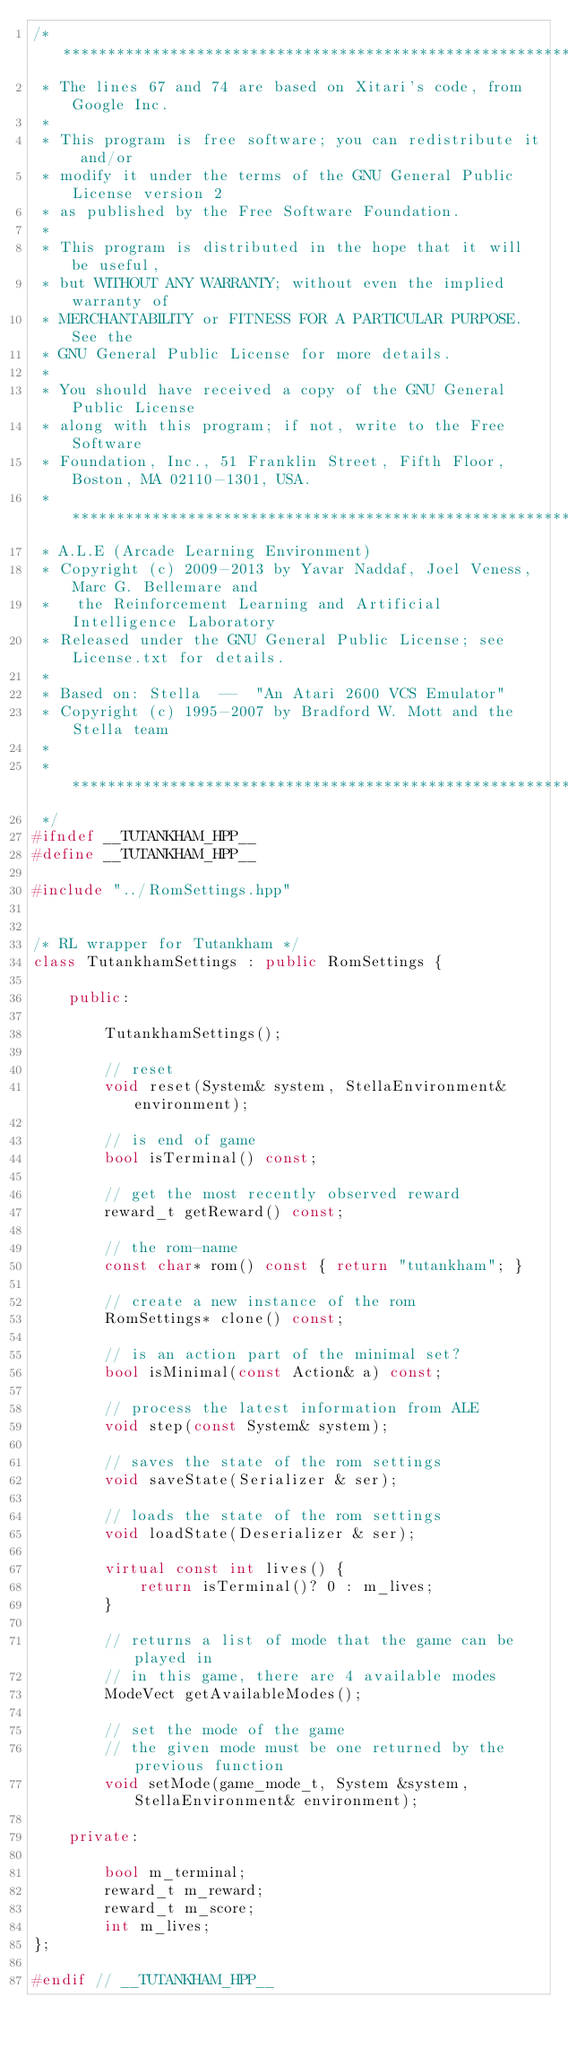Convert code to text. <code><loc_0><loc_0><loc_500><loc_500><_C++_>/* *****************************************************************************
 * The lines 67 and 74 are based on Xitari's code, from Google Inc.
 *
 * This program is free software; you can redistribute it and/or
 * modify it under the terms of the GNU General Public License version 2
 * as published by the Free Software Foundation.
 *
 * This program is distributed in the hope that it will be useful,
 * but WITHOUT ANY WARRANTY; without even the implied warranty of
 * MERCHANTABILITY or FITNESS FOR A PARTICULAR PURPOSE. See the
 * GNU General Public License for more details.
 *
 * You should have received a copy of the GNU General Public License
 * along with this program; if not, write to the Free Software
 * Foundation, Inc., 51 Franklin Street, Fifth Floor, Boston, MA 02110-1301, USA.
 * *****************************************************************************
 * A.L.E (Arcade Learning Environment)
 * Copyright (c) 2009-2013 by Yavar Naddaf, Joel Veness, Marc G. Bellemare and 
 *   the Reinforcement Learning and Artificial Intelligence Laboratory
 * Released under the GNU General Public License; see License.txt for details. 
 *
 * Based on: Stella  --  "An Atari 2600 VCS Emulator"
 * Copyright (c) 1995-2007 by Bradford W. Mott and the Stella team
 *
 * *****************************************************************************
 */
#ifndef __TUTANKHAM_HPP__
#define __TUTANKHAM_HPP__

#include "../RomSettings.hpp"


/* RL wrapper for Tutankham */
class TutankhamSettings : public RomSettings {

    public:

        TutankhamSettings();

        // reset
        void reset(System& system, StellaEnvironment& environment);

        // is end of game
        bool isTerminal() const;

        // get the most recently observed reward
        reward_t getReward() const;

        // the rom-name
        const char* rom() const { return "tutankham"; }

        // create a new instance of the rom
        RomSettings* clone() const;

        // is an action part of the minimal set?
        bool isMinimal(const Action& a) const;

        // process the latest information from ALE
        void step(const System& system);

        // saves the state of the rom settings
        void saveState(Serializer & ser);
    
        // loads the state of the rom settings
        void loadState(Deserializer & ser);

        virtual const int lives() {
            return isTerminal()? 0 : m_lives;
        }

        // returns a list of mode that the game can be played in
        // in this game, there are 4 available modes
        ModeVect getAvailableModes();

        // set the mode of the game
        // the given mode must be one returned by the previous function
        void setMode(game_mode_t, System &system, StellaEnvironment& environment);

    private:

        bool m_terminal;
        reward_t m_reward;
        reward_t m_score;
        int m_lives;
};

#endif // __TUTANKHAM_HPP__

</code> 